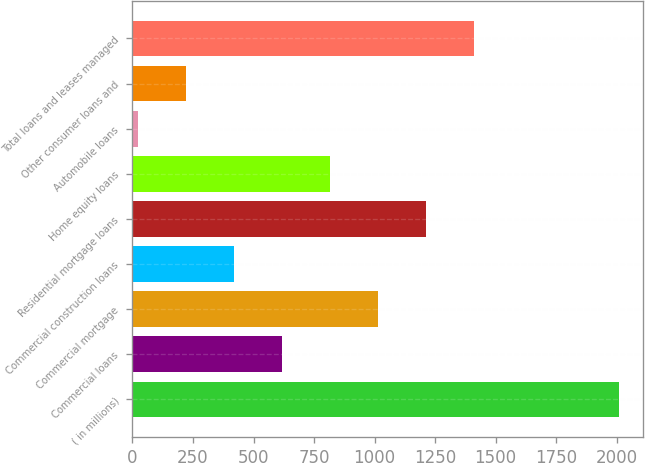Convert chart. <chart><loc_0><loc_0><loc_500><loc_500><bar_chart><fcel>( in millions)<fcel>Commercial loans<fcel>Commercial mortgage<fcel>Commercial construction loans<fcel>Residential mortgage loans<fcel>Home equity loans<fcel>Automobile loans<fcel>Other consumer loans and<fcel>Total loans and leases managed<nl><fcel>2008<fcel>617.8<fcel>1015<fcel>419.2<fcel>1213.6<fcel>816.4<fcel>22<fcel>220.6<fcel>1412.2<nl></chart> 